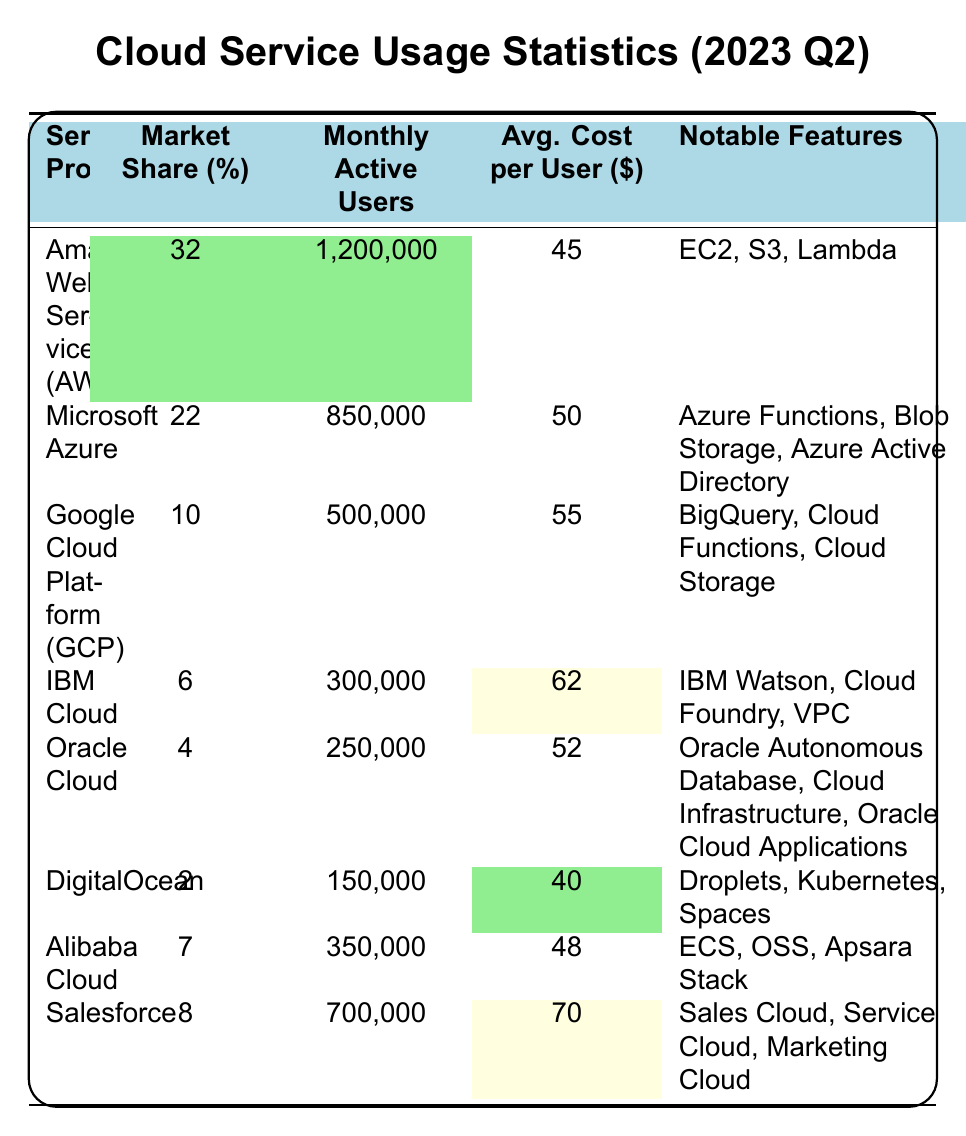What is the market share percentage of Amazon Web Services? The market share percentage for Amazon Web Services is explicitly listed in the table as 32%.
Answer: 32% How many monthly active users does Microsoft Azure have? The table indicates that Microsoft Azure has 850,000 monthly active users.
Answer: 850,000 What is the average cost per user for Google Cloud Platform? According to the table, the average cost per user for Google Cloud Platform is 55 dollars.
Answer: 55 Which cloud service provider has the highest market share percentage? Amazon Web Services has the highest market share percentage, which is marked as 32% in the table.
Answer: Amazon Web Services How does the average cost per user compare between AWS and DigitalOcean? The average cost per user for AWS is 45 dollars, while for DigitalOcean, it is 40 dollars; AWS cost is higher by 5 dollars.
Answer: AWS is higher by 5 dollars What is the total number of monthly active users across all listed cloud service providers? To find the total, add each provider's monthly active users: 1,200,000 + 850,000 + 500,000 + 300,000 + 250,000 + 150,000 + 350,000 + 700,000 = 4,300,000.
Answer: 4,300,000 Do more than half of the monthly active users belong to AWS and Microsoft Azure combined? AWS has 1,200,000 and Azure has 850,000, totaling 2,050,000, which is less than half of 4,300,000; therefore, the statement is false.
Answer: No Which service provider has the highest average cost per user? Salesforce has the highest average cost per user at 70 dollars, according to the table.
Answer: Salesforce If IBM Cloud increases its monthly active users by 100,000, what will be the new total? Currently, IBM Cloud has 300,000 users; adding 100,000 would result in 400,000 users (300,000 + 100,000).
Answer: 400,000 What is the difference in market share percentage between Salesforce and Oracle Cloud? Salesforce has 8% and Oracle Cloud has 4%; the difference is 8% - 4% = 4%.
Answer: 4% If you combine the monthly active users of Alibaba Cloud and DigitalOcean, how many do you have? Alibaba Cloud has 350,000 and DigitalOcean has 150,000; the sum is 350,000 + 150,000 = 500,000 users.
Answer: 500,000 Is there a cloud service provider with a market share of less than 5%? Yes, both Oracle Cloud (4%) and DigitalOcean (2%) have market shares below 5%. The statement is true.
Answer: Yes Which cloud service provider offers the feature "IBM Watson"? The feature "IBM Watson" is offered by IBM Cloud, as indicated in the notable features column.
Answer: IBM Cloud What is the average of the average costs per user for all providers? The average cost per user can be calculated: (45 + 50 + 55 + 62 + 52 + 40 + 48 + 70)/8 = 52.
Answer: 52 